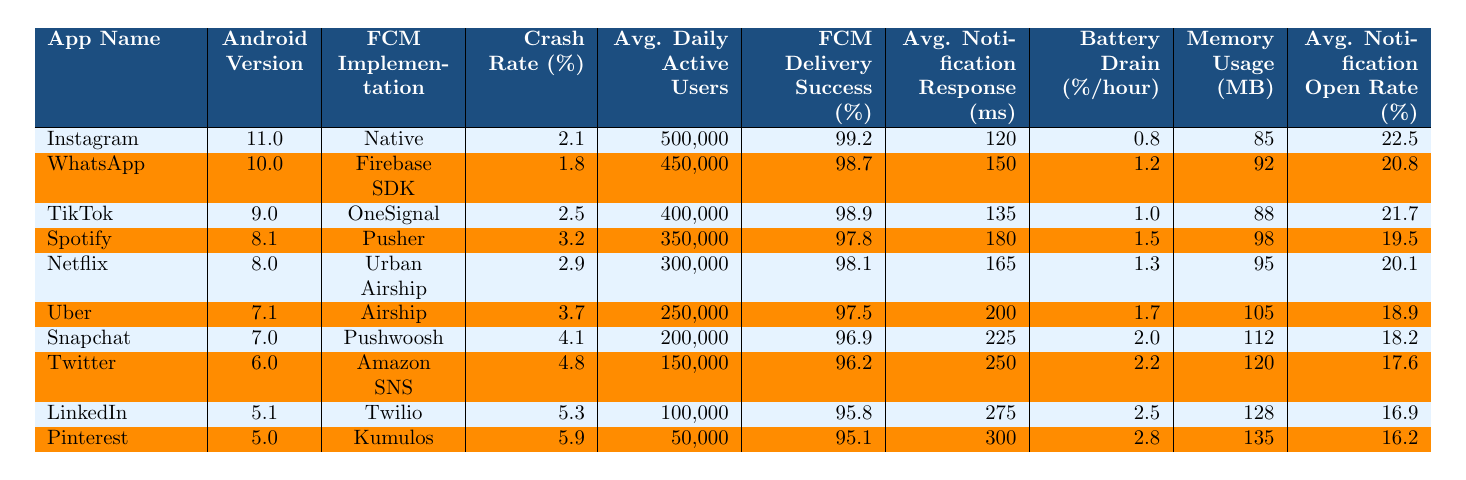What is the crash rate percentage for Instagram? By looking at the table, the crash rate percentage for Instagram is listed under the "Crash Rate (%)" column for the "Instagram" row. The value is 2.1%.
Answer: 2.1% Which FCM implementation has the highest FCM delivery success rate? The table shows the "FCM Delivery Success (%)" for each FCM implementation. Upon examining the values, the "Native" FCM implementation has the highest success rate at 99.2%.
Answer: Native What is the average notification open rate for apps using Firebase SDK? The open rate for WhatsApp, which uses the Firebase SDK, is 20.8%. Since it is the only app listed with this implementation, this is the average open rate.
Answer: 20.8% Is there any app with a crash rate higher than 4%? The table indicates that both Snapchat (4.1%) and Twitter (4.8%) have crash rates exceeding 4%. Thus, there are apps with a crash rate higher than 4%.
Answer: Yes What is the difference in crash rate percentage between LinkedIn and Pinterest? LinkedIn has a crash rate of 5.3% and Pinterest has a crash rate of 5.9%. The difference is calculated by subtracting LinkedIn's rate from Pinterest's: 5.9% - 5.3% = 0.6%.
Answer: 0.6% Which app with the least average daily active users has the highest battery drain percentage? Examining the table, Pinterest has the least average daily active users (50,000) and the highest battery drain percentage among the apps (2.8%).
Answer: Pinterest What is the average crash rate for apps developed with OneSignal and Pusher? The crash rates for OneSignal (TikTok) and Pusher (Spotify) are 2.5% and 3.2%, respectively. To find the average, add the two rates (2.5% + 3.2% = 5.7%) and divide by 2. The average is 5.7% / 2 = 2.85%.
Answer: 2.85% Which app has the lowest FCM delivery success rate and what is that rate? By reviewing the "FCM Delivery Success (%)" column, we find that Pinterest is the app with the lowest delivery success rate at 95.1%.
Answer: 95.1% What is the combined battery drain percentage for Uber and Netflix? The battery drain percentage for Uber is 1.7% and for Netflix is 1.3%. Adding these together gives a combined total of 1.7% + 1.3% = 3.0%.
Answer: 3.0% Does higher memory usage correlate with higher crash rates in this data? Reviewing the data, we observe that higher memory usage does not consistently correlate with higher crash rates, as seen with Uber (105 MB, 3.7%) and Instagram (85 MB, 2.1%). This indicates that there are exceptions where higher memory does not equate to higher crash rates.
Answer: No 